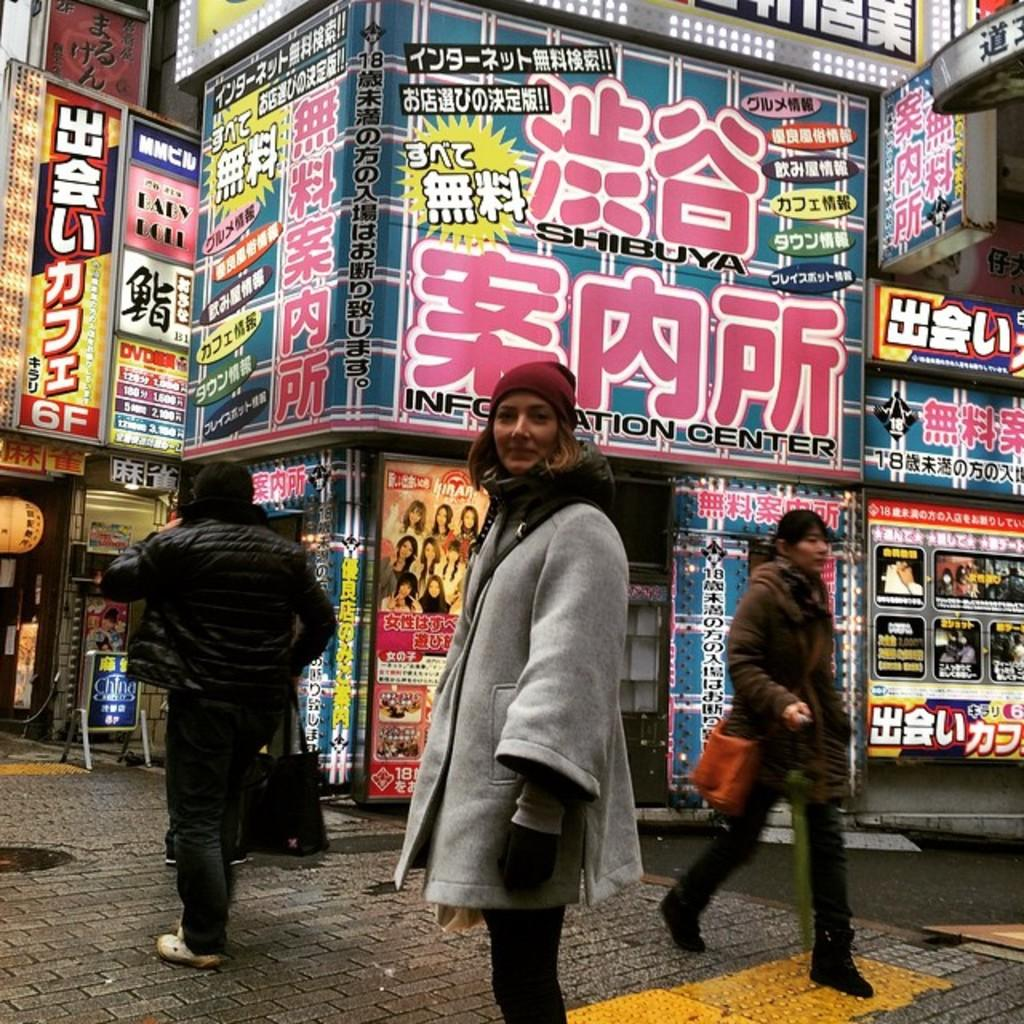What is the main subject of the image? There is a woman standing in the image. What else can be seen in the image besides the woman? There are people walking on the road and display boards on the buildings in the image. What type of fiction is the woman reading in the image? There is no book or any indication of reading in the image, so it cannot be determined if the woman is reading fiction or any other type of material. 